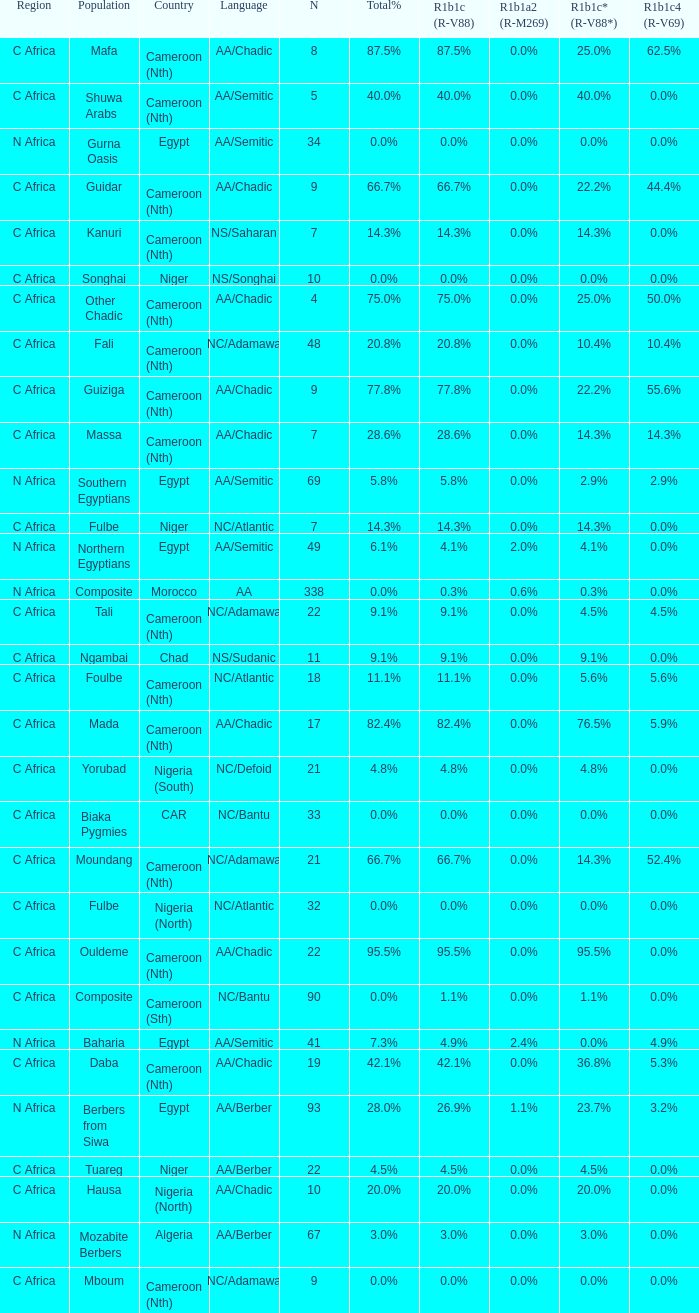What languages are spoken in Niger with r1b1c (r-v88) of 0.0%? NS/Songhai. 